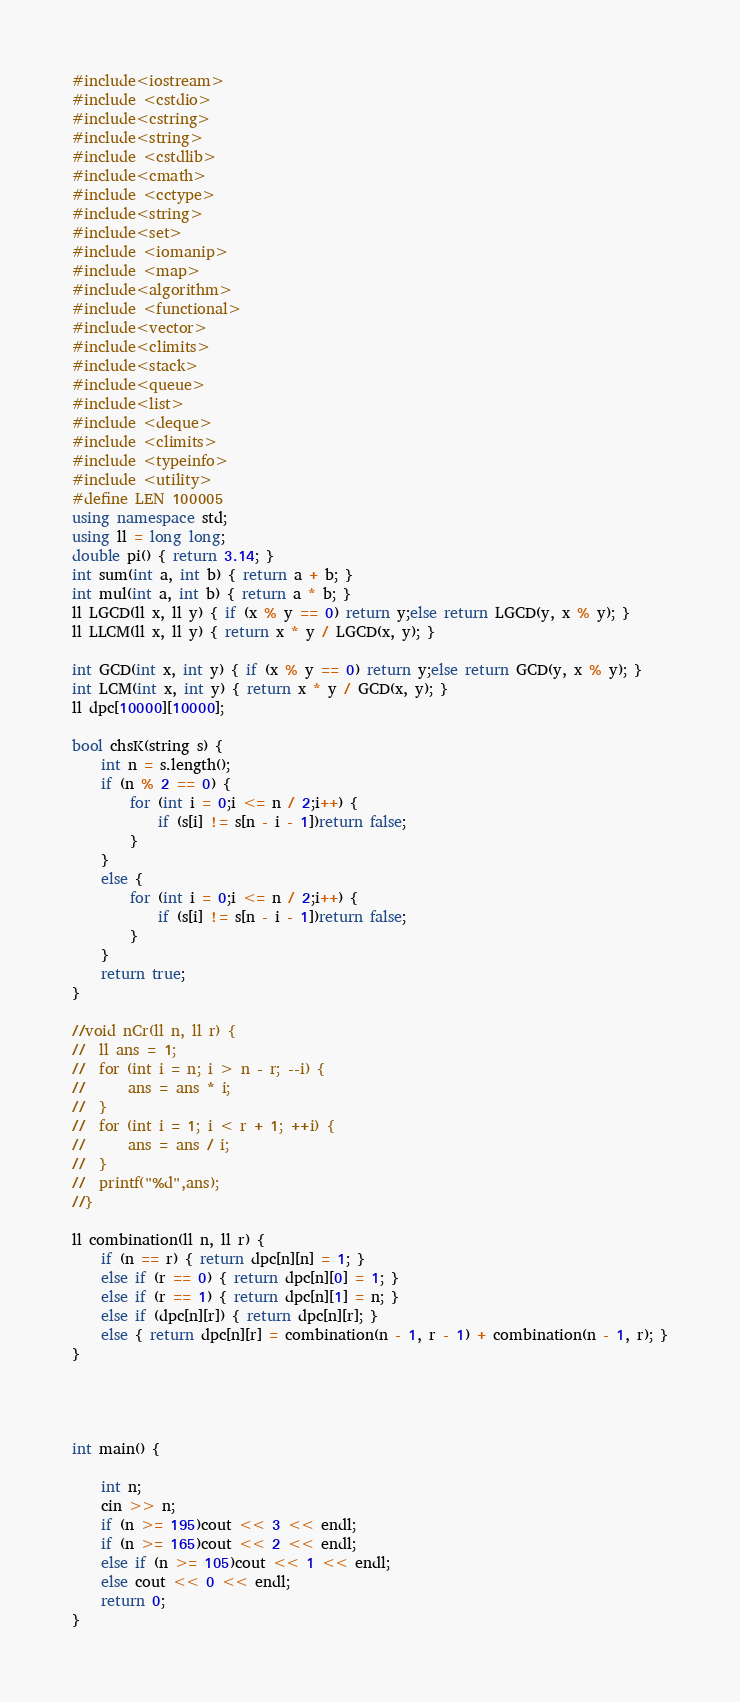Convert code to text. <code><loc_0><loc_0><loc_500><loc_500><_C++_>#include<iostream>
#include <cstdio>
#include<cstring>
#include<string>
#include <cstdlib>  
#include<cmath>   
#include <cctype>
#include<string>
#include<set>
#include <iomanip>
#include <map>
#include<algorithm>
#include <functional>
#include<vector>
#include<climits>
#include<stack>
#include<queue>
#include<list>
#include <deque>
#include <climits>
#include <typeinfo>
#include <utility>
#define LEN 100005
using namespace std;
using ll = long long;
double pi() { return 3.14; }
int sum(int a, int b) { return a + b; }
int mul(int a, int b) { return a * b; }
ll LGCD(ll x, ll y) { if (x % y == 0) return y;else return LGCD(y, x % y); }
ll LLCM(ll x, ll y) { return x * y / LGCD(x, y); }

int GCD(int x, int y) { if (x % y == 0) return y;else return GCD(y, x % y); }
int LCM(int x, int y) { return x * y / GCD(x, y); }
ll dpc[10000][10000];

bool chsK(string s) {
	int n = s.length();
	if (n % 2 == 0) {
		for (int i = 0;i <= n / 2;i++) {
			if (s[i] != s[n - i - 1])return false;
		}
	}
	else {
		for (int i = 0;i <= n / 2;i++) {
			if (s[i] != s[n - i - 1])return false;
		}
	}
	return true;
}

//void nCr(ll n, ll r) {
//	ll ans = 1;
//	for (int i = n; i > n - r; --i) {
//		ans = ans * i;
//	}
//	for (int i = 1; i < r + 1; ++i) {
//		ans = ans / i;
//	}
//	printf("%d",ans);
//}

ll combination(ll n, ll r) {
	if (n == r) { return dpc[n][n] = 1; }
	else if (r == 0) { return dpc[n][0] = 1; }
	else if (r == 1) { return dpc[n][1] = n; }
	else if (dpc[n][r]) { return dpc[n][r]; }
	else { return dpc[n][r] = combination(n - 1, r - 1) + combination(n - 1, r); }
}




int main() {
	
	int n;
	cin >> n;
	if (n >= 195)cout << 3 << endl;
	if (n >= 165)cout << 2 << endl;
	else if (n >= 105)cout << 1 << endl;
	else cout << 0 << endl;
	return 0;
}</code> 